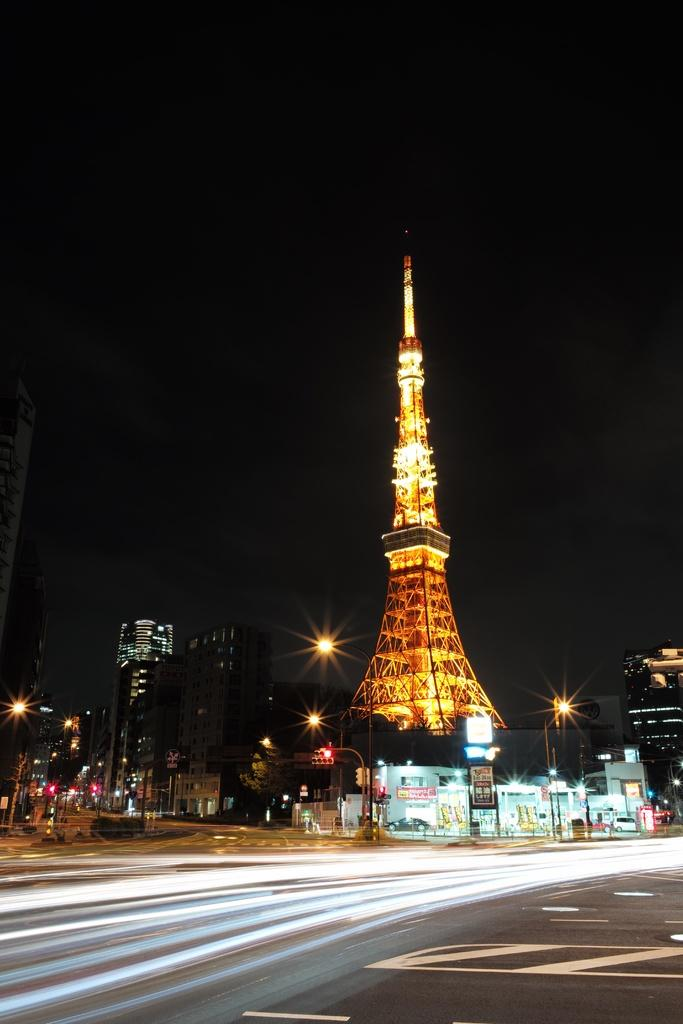What type of structures can be seen in the image? There are buildings and a tower in the image. Can you describe the lighting in the image? The buildings and tower have lighting. What type of illumination is present in the image? Pole lights are present in the image. What is the purpose of the pole lights? The pole lights provide illumination for the buildings, tower, and road. What is visible on the ground in the image? There is a road visible in the image. What type of tank is visible in the image? There is no tank present in the image. What is the starting point for the road in the image? The image does not show a starting point for the road, only a portion of the road itself. 